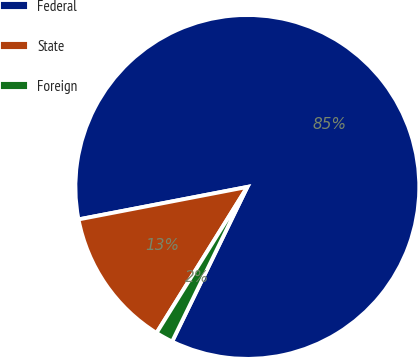<chart> <loc_0><loc_0><loc_500><loc_500><pie_chart><fcel>Federal<fcel>State<fcel>Foreign<nl><fcel>85.24%<fcel>13.12%<fcel>1.65%<nl></chart> 